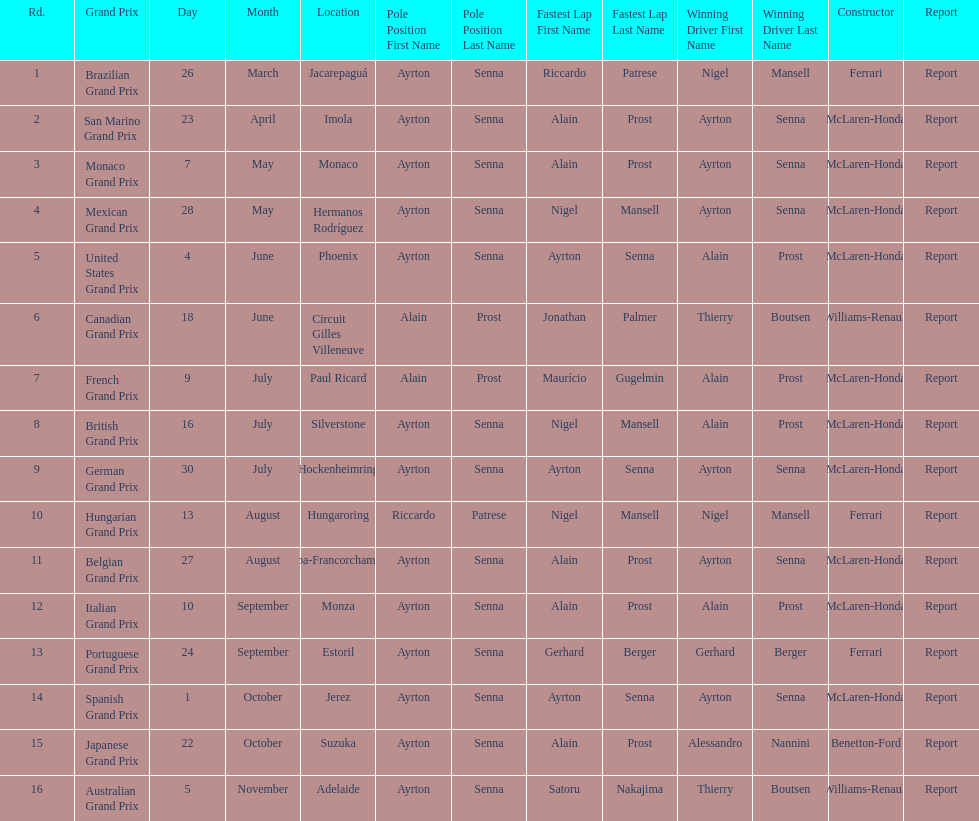What grand prix was before the san marino grand prix? Brazilian Grand Prix. 